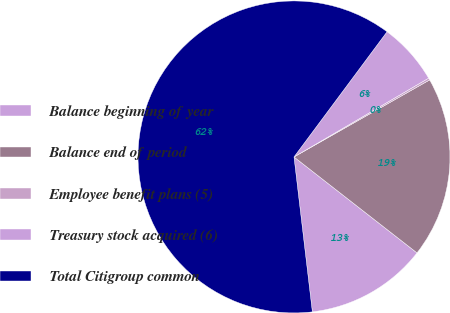Convert chart to OTSL. <chart><loc_0><loc_0><loc_500><loc_500><pie_chart><fcel>Balance beginning of year<fcel>Balance end of period<fcel>Employee benefit plans (5)<fcel>Treasury stock acquired (6)<fcel>Total Citigroup common<nl><fcel>12.58%<fcel>18.76%<fcel>0.21%<fcel>6.4%<fcel>62.05%<nl></chart> 